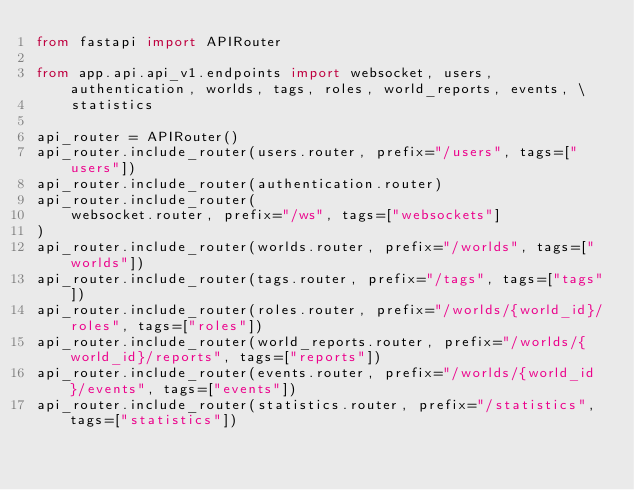<code> <loc_0><loc_0><loc_500><loc_500><_Python_>from fastapi import APIRouter

from app.api.api_v1.endpoints import websocket, users, authentication, worlds, tags, roles, world_reports, events, \
    statistics

api_router = APIRouter()
api_router.include_router(users.router, prefix="/users", tags=["users"])
api_router.include_router(authentication.router)
api_router.include_router(
    websocket.router, prefix="/ws", tags=["websockets"]
)
api_router.include_router(worlds.router, prefix="/worlds", tags=["worlds"])
api_router.include_router(tags.router, prefix="/tags", tags=["tags"])
api_router.include_router(roles.router, prefix="/worlds/{world_id}/roles", tags=["roles"])
api_router.include_router(world_reports.router, prefix="/worlds/{world_id}/reports", tags=["reports"])
api_router.include_router(events.router, prefix="/worlds/{world_id}/events", tags=["events"])
api_router.include_router(statistics.router, prefix="/statistics", tags=["statistics"])
</code> 